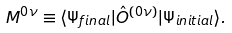<formula> <loc_0><loc_0><loc_500><loc_500>M ^ { 0 \nu } \equiv \langle \Psi _ { f i n a l } | \hat { O } ^ { ( 0 \nu ) } | \Psi _ { i n i t i a l } \rangle .</formula> 